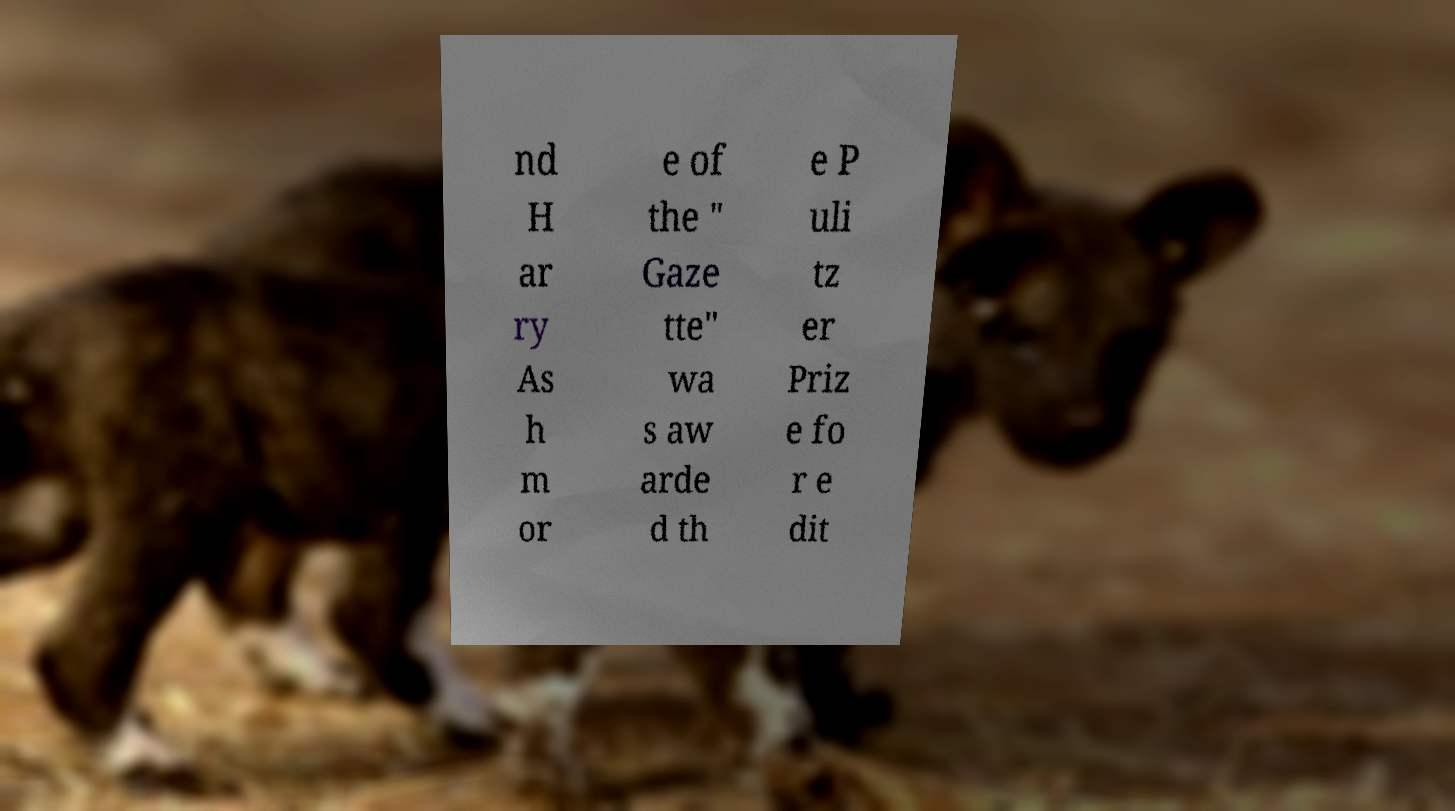Please read and relay the text visible in this image. What does it say? nd H ar ry As h m or e of the " Gaze tte" wa s aw arde d th e P uli tz er Priz e fo r e dit 